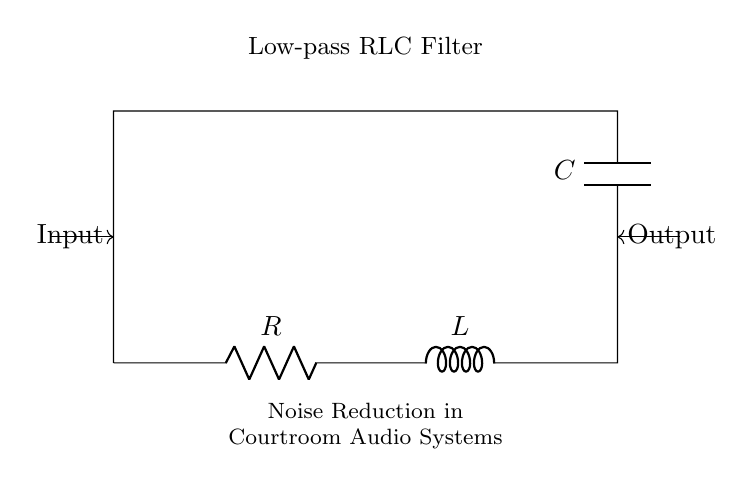What type of filter is represented in the circuit? The diagram clearly labels the function of the circuit as a Low-pass RLC Filter, which indicates that it is designed to allow low-frequency signals to pass while attenuating high-frequency signals.
Answer: Low-pass RLC Filter What are the components of the circuit? Observing the diagram, we can identify three primary components: a resistor (R), an inductor (L), and a capacitor (C), as labeled. These are standard components for constructing an RLC circuit.
Answer: Resistor, Inductor, Capacitor What is the output connection position relative to the input? The diagram shows the output connection located at the top of the capacitor, while the input is at the left side of the circuit. This indicates that the signal flows from the input through the components to the output.
Answer: Above the capacitor How does the connection of the capacitor affect the circuit? The capacitor is connected in parallel with the output, which means it allows AC signals to pass while blocking DC components, contributing to noise reduction by filtering out high-frequency noise.
Answer: It filters high frequencies What happens to high-frequency signals in this circuit? In a low-pass RLC filter configuration, high-frequency signals face impedance due to the inductor and capacitor; therefore, they cannot pass effectively through the circuit, resulting in attenuation of those frequencies.
Answer: They are attenuated What is the significance of using a low-pass filter in courtroom audio systems? A low-pass filter effectively minimizes unwanted high-frequency noise, ensuring clearer audio transmission of speech, which is critical for understanding proceedings in a courtroom environment.
Answer: It reduces noise for clearer audio 